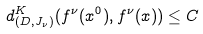<formula> <loc_0><loc_0><loc_500><loc_500>d _ { ( D , J _ { \nu } ) } ^ { K } ( f ^ { \nu } ( x ^ { 0 } ) , f ^ { \nu } ( x ) ) \leq C</formula> 